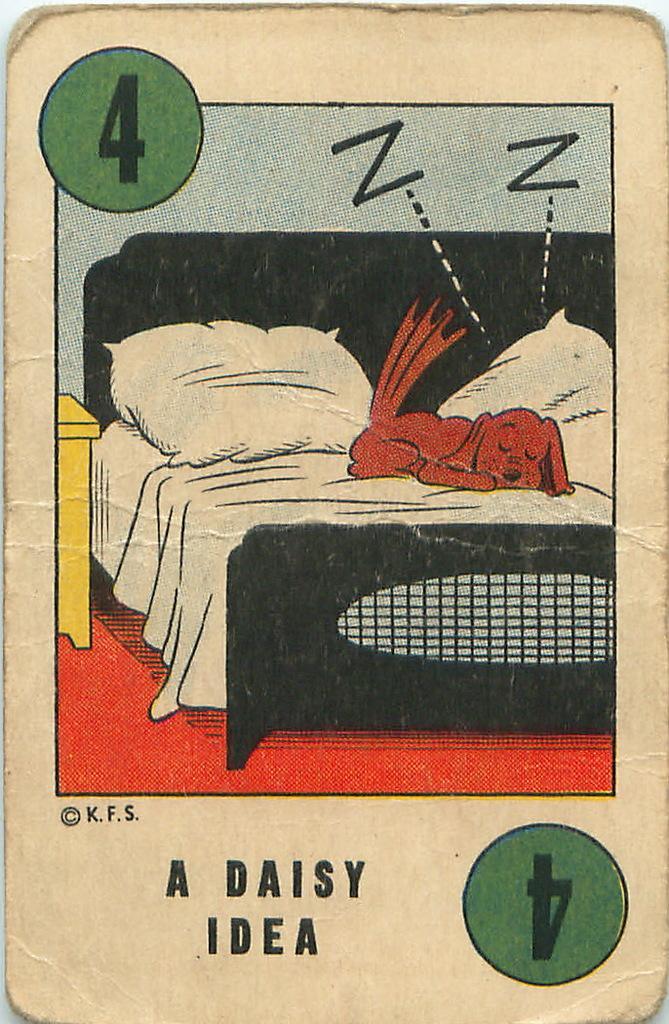Describe this image in one or two sentences. This looks like a card. I can see the picture of a dog sleeping on a bed. These are the pillows. I can see the numbers and letters on the card. 